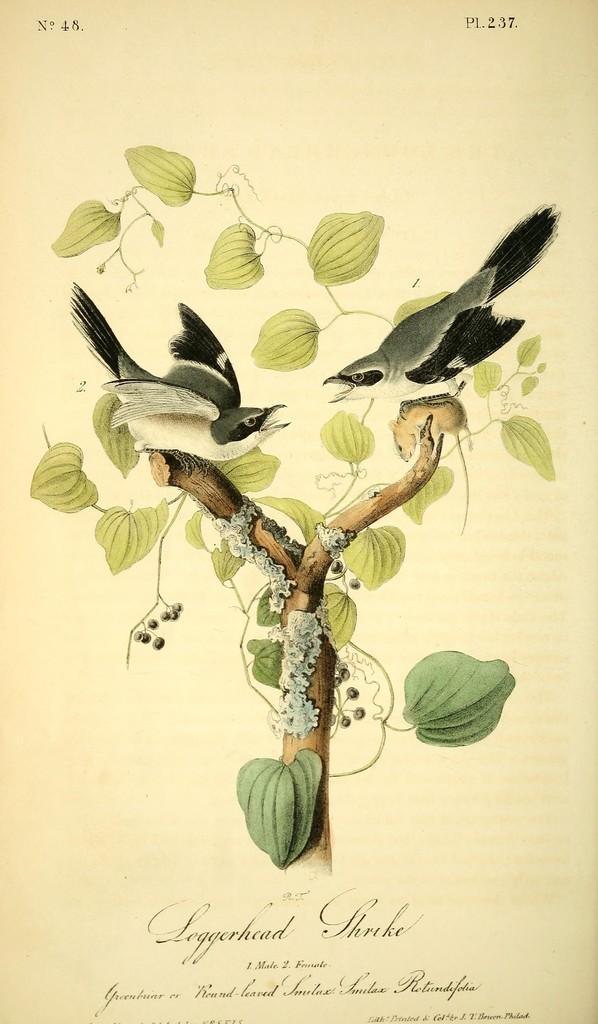Can you describe this image briefly? In this image we can see the painting of a tree with fruits, two birds on the tree, some text on the bottom of the image, one rat on the tree, there is a cream color background, some text on the top right and left side corner of the image. 